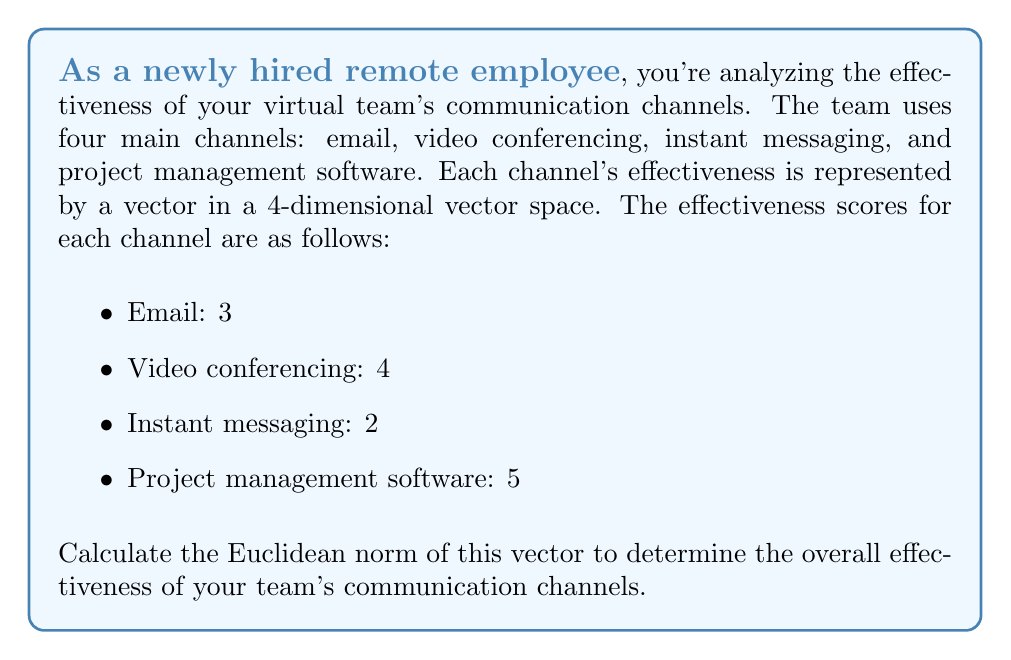Give your solution to this math problem. To solve this problem, we'll follow these steps:

1. Identify the vector:
   The vector representing the effectiveness of communication channels is:
   $$v = (3, 4, 2, 5)$$

2. Recall the formula for Euclidean norm:
   For a vector $v = (v_1, v_2, ..., v_n)$, the Euclidean norm is given by:
   $$\|v\| = \sqrt{v_1^2 + v_2^2 + ... + v_n^2}$$

3. Apply the formula to our vector:
   $$\|v\| = \sqrt{3^2 + 4^2 + 2^2 + 5^2}$$

4. Calculate the squares:
   $$\|v\| = \sqrt{9 + 16 + 4 + 25}$$

5. Sum the squares:
   $$\|v\| = \sqrt{54}$$

6. Simplify the square root:
   $$\|v\| = 3\sqrt{6}$$

This result represents the overall effectiveness of the team's communication channels as measured by the Euclidean norm of the effectiveness scores.
Answer: $3\sqrt{6}$ 